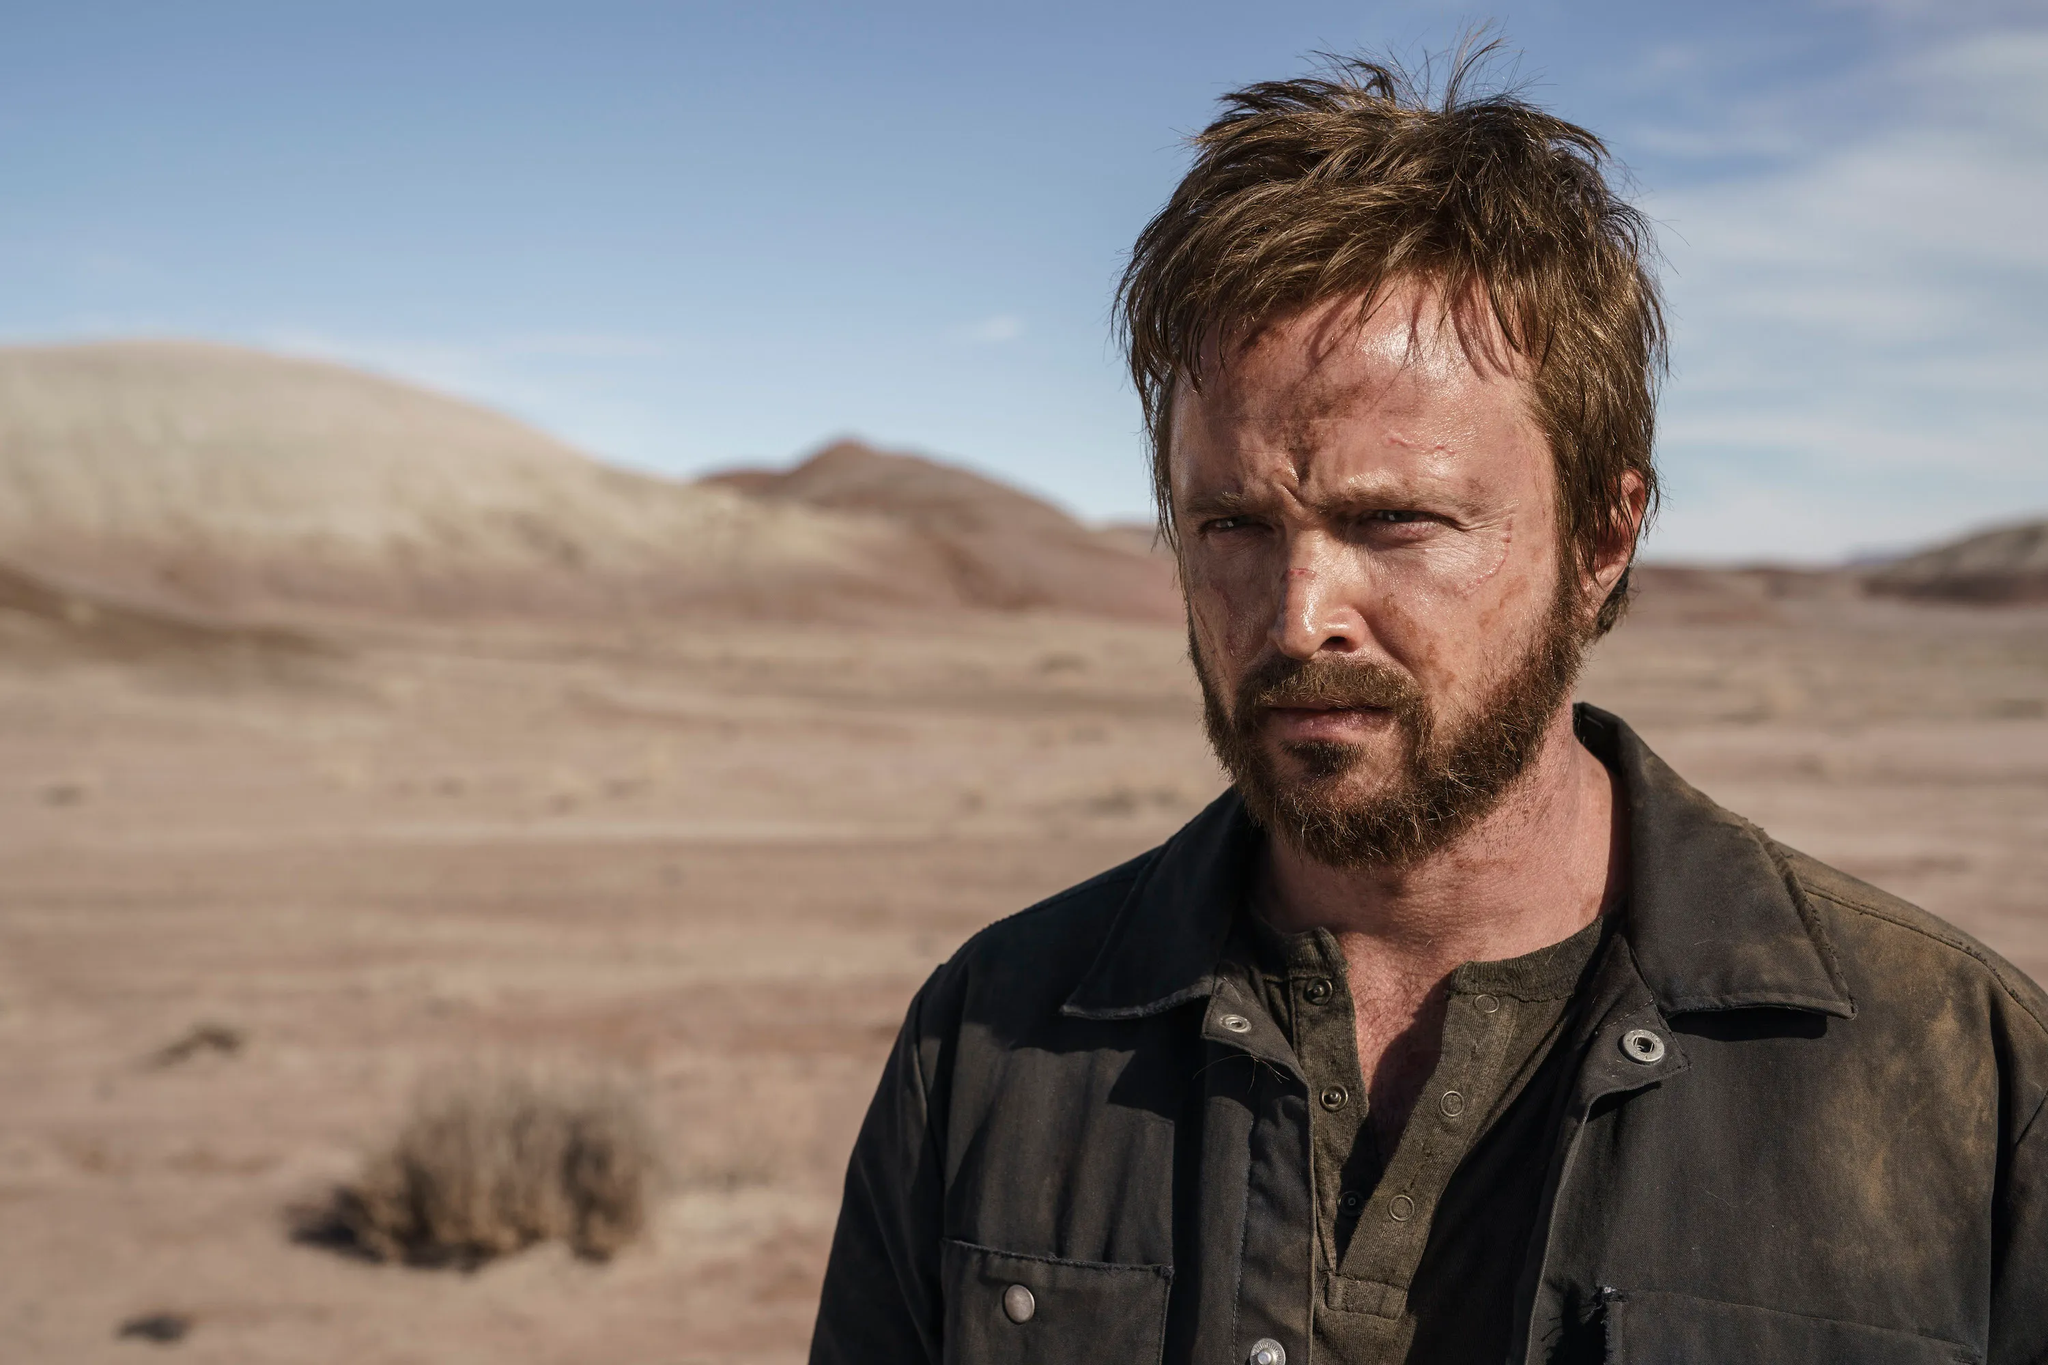What's happening in the scene? In the image, there is a man standing in a vast desert landscape. He is dressed in a rugged, dark jacket which indicates a possibly harsh outdoor setting or an adventurous scenario. His expression is intense and thoughtful, with a light beard and unkempt hair, suggesting that he might be deep in thought or dealing with a serious situation. The desert around him is barren with a few sparse bushes and distant mountains, enhancing the sense of isolation and solemnity of the scene. 